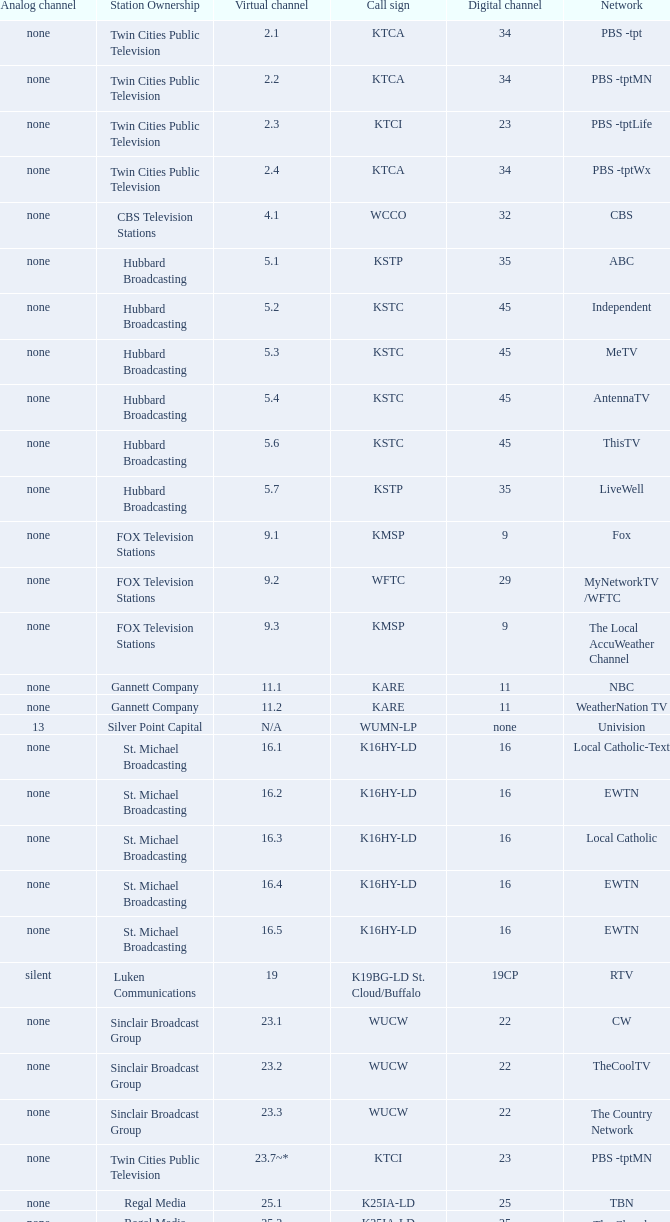Digital channel of 32 belongs to what analog channel? None. 